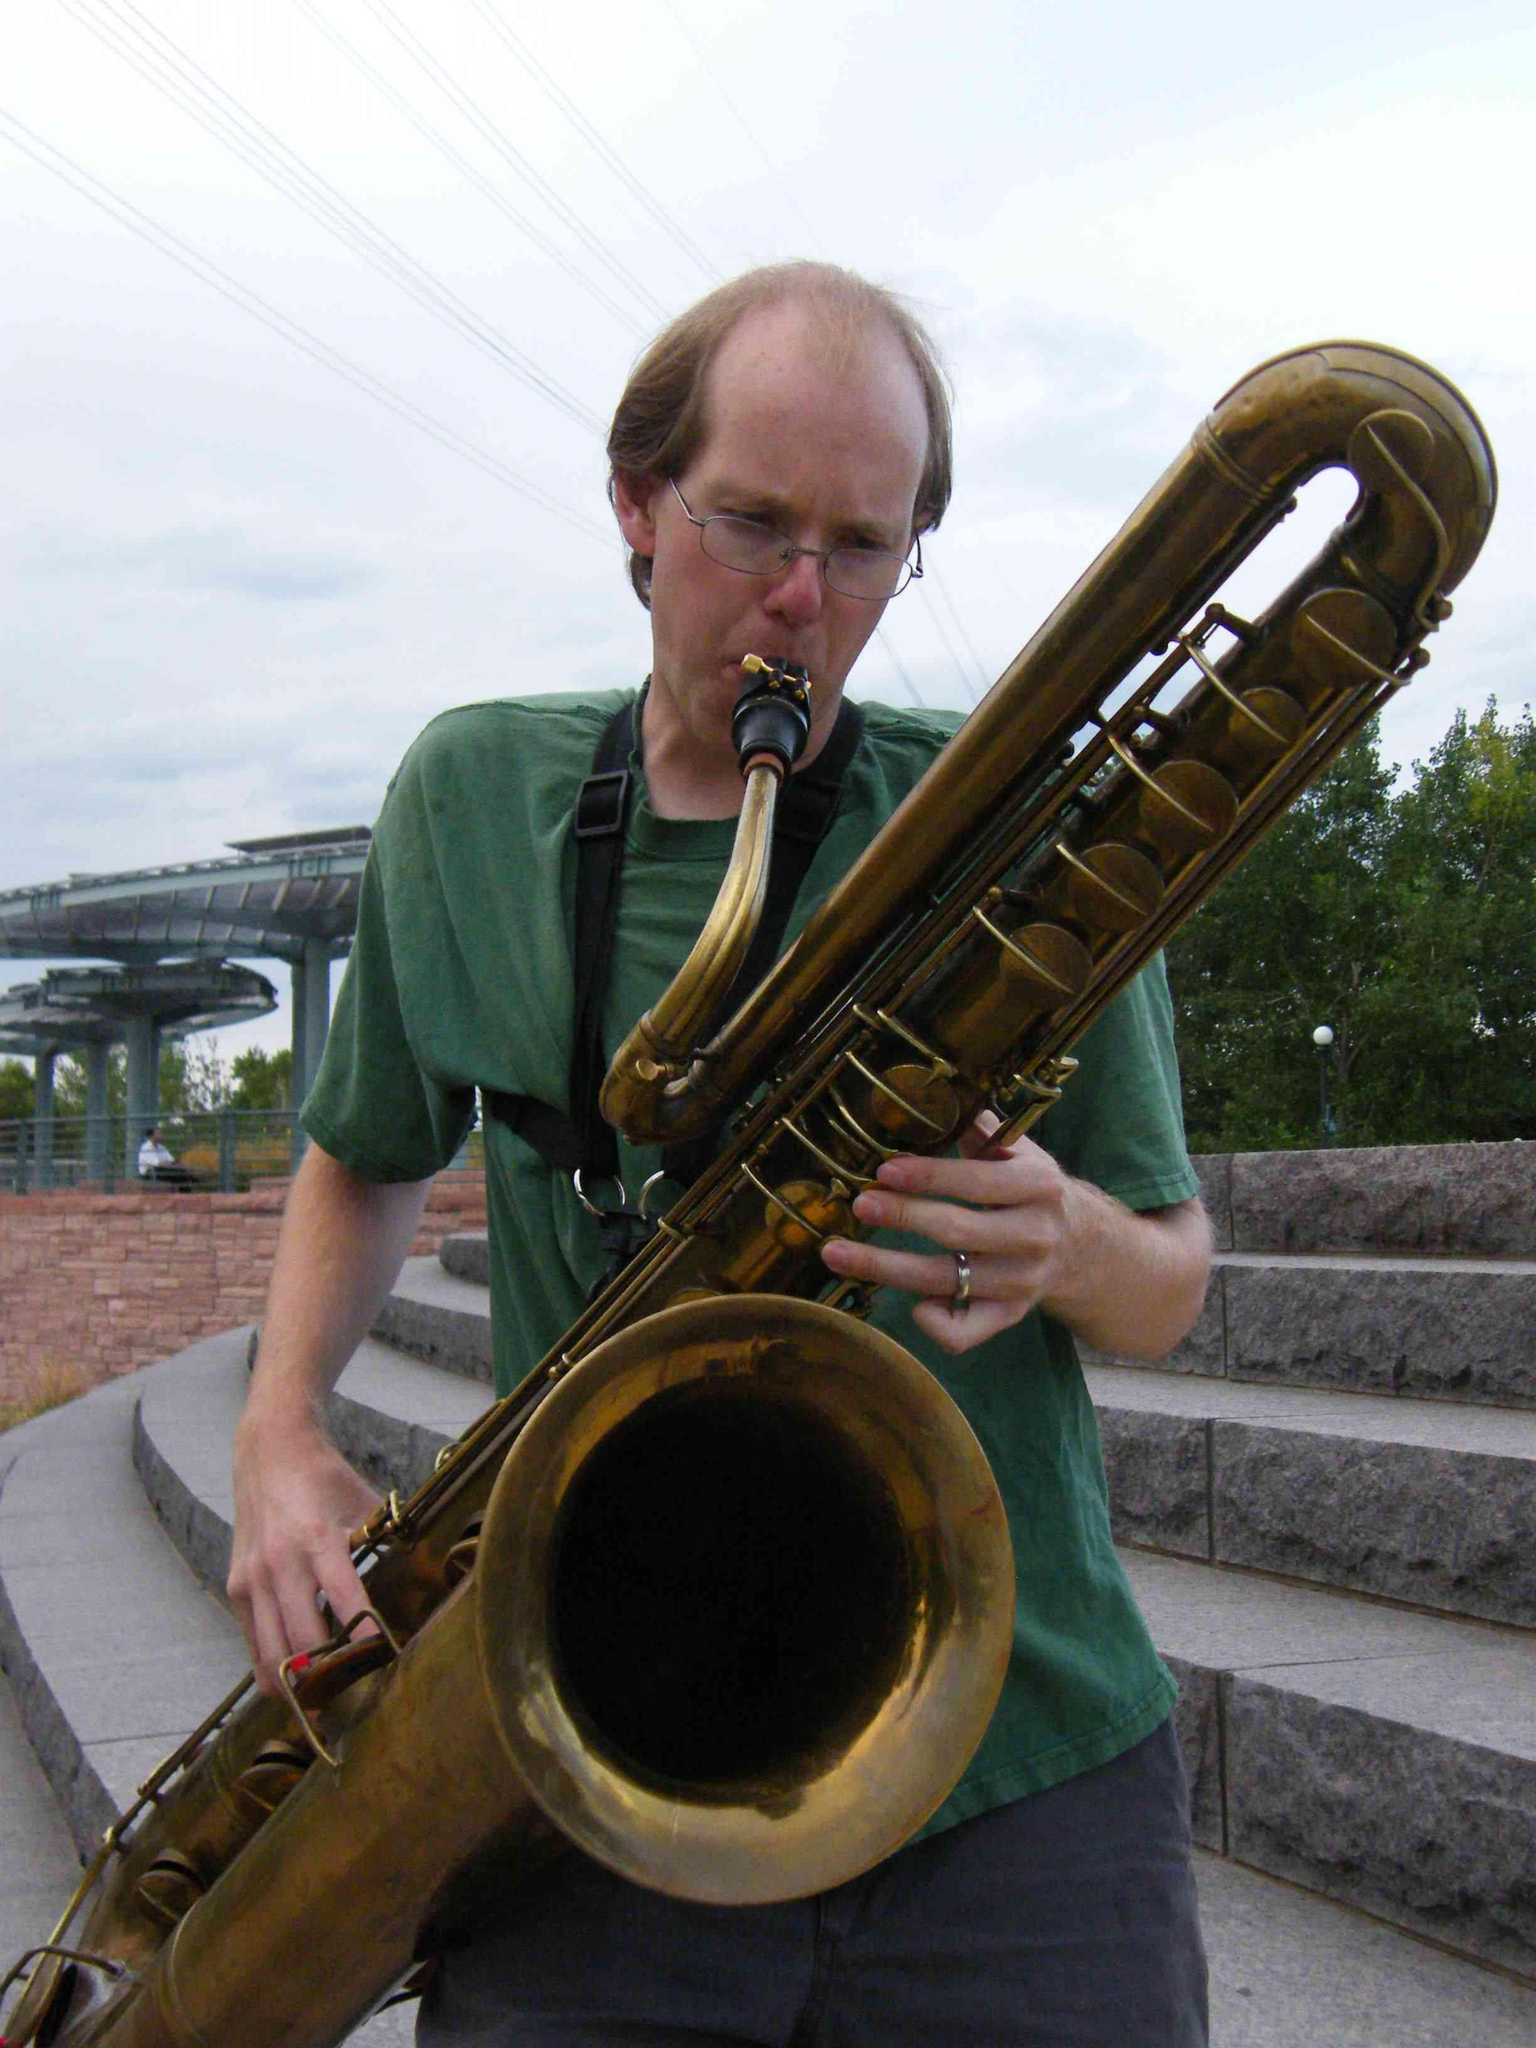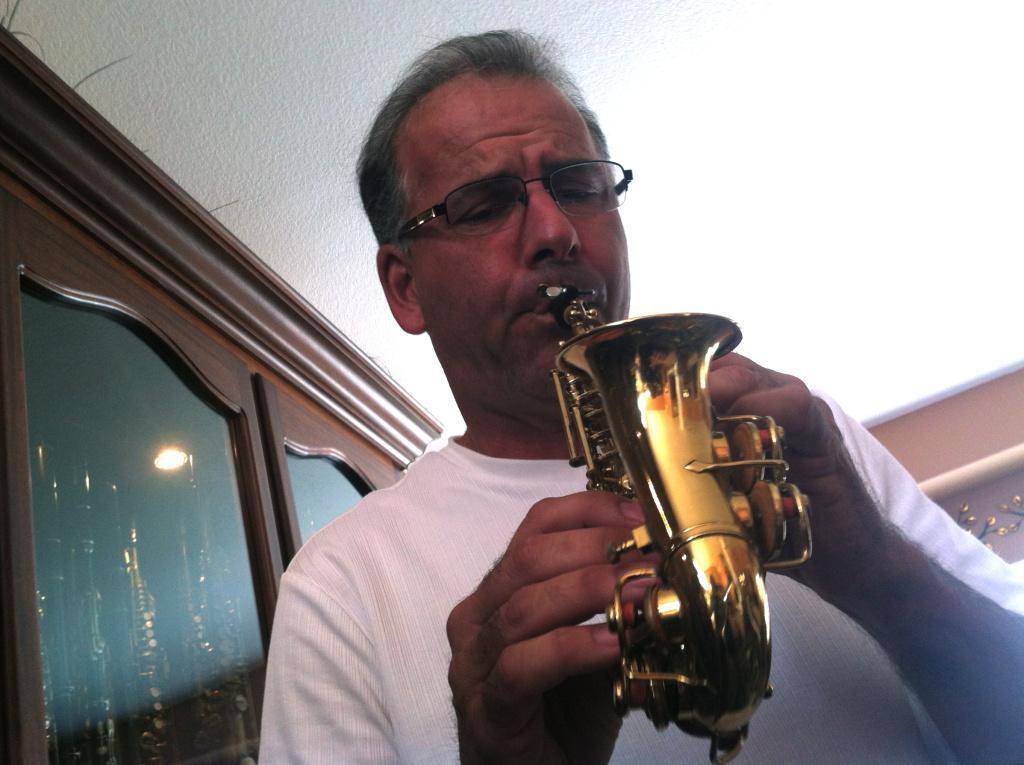The first image is the image on the left, the second image is the image on the right. For the images displayed, is the sentence "Two people are playing instruments." factually correct? Answer yes or no. Yes. The first image is the image on the left, the second image is the image on the right. Assess this claim about the two images: "One man is standing and blowing into the mouthpiece of a brass instrument positioned diagonally to the right.". Correct or not? Answer yes or no. Yes. 